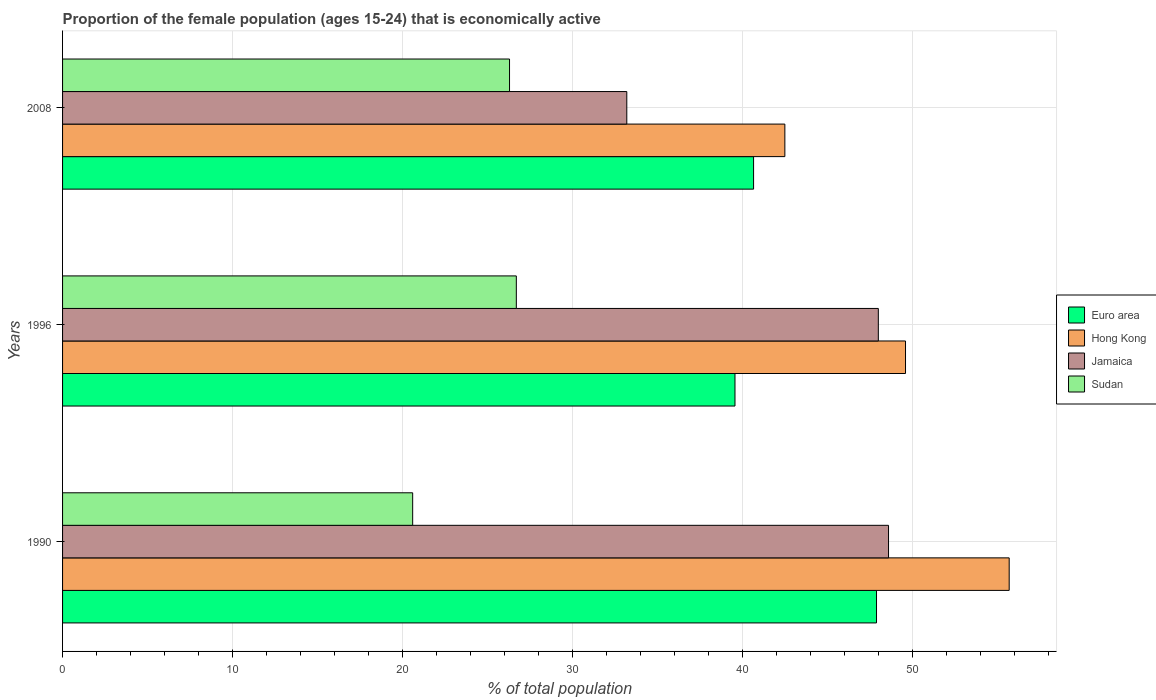How many groups of bars are there?
Make the answer very short. 3. Are the number of bars per tick equal to the number of legend labels?
Offer a very short reply. Yes. How many bars are there on the 2nd tick from the bottom?
Offer a terse response. 4. What is the proportion of the female population that is economically active in Sudan in 1996?
Your answer should be very brief. 26.7. Across all years, what is the maximum proportion of the female population that is economically active in Hong Kong?
Ensure brevity in your answer.  55.7. Across all years, what is the minimum proportion of the female population that is economically active in Jamaica?
Your answer should be compact. 33.2. In which year was the proportion of the female population that is economically active in Jamaica maximum?
Provide a succinct answer. 1990. What is the total proportion of the female population that is economically active in Jamaica in the graph?
Offer a terse response. 129.8. What is the difference between the proportion of the female population that is economically active in Euro area in 1990 and that in 2008?
Provide a short and direct response. 7.23. What is the difference between the proportion of the female population that is economically active in Euro area in 1990 and the proportion of the female population that is economically active in Hong Kong in 1996?
Offer a very short reply. -1.71. What is the average proportion of the female population that is economically active in Euro area per year?
Provide a short and direct response. 42.71. In the year 1990, what is the difference between the proportion of the female population that is economically active in Hong Kong and proportion of the female population that is economically active in Sudan?
Ensure brevity in your answer.  35.1. In how many years, is the proportion of the female population that is economically active in Jamaica greater than 56 %?
Offer a very short reply. 0. What is the ratio of the proportion of the female population that is economically active in Sudan in 1996 to that in 2008?
Offer a very short reply. 1.02. Is the difference between the proportion of the female population that is economically active in Hong Kong in 1990 and 2008 greater than the difference between the proportion of the female population that is economically active in Sudan in 1990 and 2008?
Provide a succinct answer. Yes. What is the difference between the highest and the second highest proportion of the female population that is economically active in Sudan?
Provide a succinct answer. 0.4. What is the difference between the highest and the lowest proportion of the female population that is economically active in Hong Kong?
Your answer should be compact. 13.2. Is the sum of the proportion of the female population that is economically active in Jamaica in 1990 and 1996 greater than the maximum proportion of the female population that is economically active in Euro area across all years?
Your answer should be very brief. Yes. What does the 3rd bar from the top in 1996 represents?
Provide a short and direct response. Hong Kong. What does the 3rd bar from the bottom in 1996 represents?
Offer a terse response. Jamaica. Is it the case that in every year, the sum of the proportion of the female population that is economically active in Euro area and proportion of the female population that is economically active in Sudan is greater than the proportion of the female population that is economically active in Hong Kong?
Offer a very short reply. Yes. How many bars are there?
Ensure brevity in your answer.  12. What is the difference between two consecutive major ticks on the X-axis?
Keep it short and to the point. 10. Does the graph contain any zero values?
Your answer should be very brief. No. Does the graph contain grids?
Your answer should be compact. Yes. What is the title of the graph?
Ensure brevity in your answer.  Proportion of the female population (ages 15-24) that is economically active. What is the label or title of the X-axis?
Make the answer very short. % of total population. What is the % of total population in Euro area in 1990?
Provide a succinct answer. 47.89. What is the % of total population in Hong Kong in 1990?
Your answer should be compact. 55.7. What is the % of total population in Jamaica in 1990?
Your response must be concise. 48.6. What is the % of total population in Sudan in 1990?
Offer a very short reply. 20.6. What is the % of total population of Euro area in 1996?
Provide a short and direct response. 39.57. What is the % of total population in Hong Kong in 1996?
Provide a succinct answer. 49.6. What is the % of total population of Jamaica in 1996?
Provide a succinct answer. 48. What is the % of total population of Sudan in 1996?
Offer a terse response. 26.7. What is the % of total population of Euro area in 2008?
Provide a short and direct response. 40.66. What is the % of total population in Hong Kong in 2008?
Provide a succinct answer. 42.5. What is the % of total population of Jamaica in 2008?
Offer a very short reply. 33.2. What is the % of total population of Sudan in 2008?
Offer a very short reply. 26.3. Across all years, what is the maximum % of total population of Euro area?
Offer a terse response. 47.89. Across all years, what is the maximum % of total population in Hong Kong?
Your answer should be very brief. 55.7. Across all years, what is the maximum % of total population of Jamaica?
Provide a succinct answer. 48.6. Across all years, what is the maximum % of total population of Sudan?
Make the answer very short. 26.7. Across all years, what is the minimum % of total population of Euro area?
Offer a very short reply. 39.57. Across all years, what is the minimum % of total population of Hong Kong?
Keep it short and to the point. 42.5. Across all years, what is the minimum % of total population in Jamaica?
Your answer should be very brief. 33.2. Across all years, what is the minimum % of total population in Sudan?
Your answer should be compact. 20.6. What is the total % of total population of Euro area in the graph?
Your answer should be compact. 128.12. What is the total % of total population in Hong Kong in the graph?
Your response must be concise. 147.8. What is the total % of total population in Jamaica in the graph?
Provide a succinct answer. 129.8. What is the total % of total population in Sudan in the graph?
Give a very brief answer. 73.6. What is the difference between the % of total population in Euro area in 1990 and that in 1996?
Your response must be concise. 8.33. What is the difference between the % of total population in Jamaica in 1990 and that in 1996?
Keep it short and to the point. 0.6. What is the difference between the % of total population in Euro area in 1990 and that in 2008?
Offer a terse response. 7.23. What is the difference between the % of total population of Jamaica in 1990 and that in 2008?
Keep it short and to the point. 15.4. What is the difference between the % of total population of Sudan in 1990 and that in 2008?
Ensure brevity in your answer.  -5.7. What is the difference between the % of total population of Euro area in 1996 and that in 2008?
Your response must be concise. -1.09. What is the difference between the % of total population of Hong Kong in 1996 and that in 2008?
Provide a succinct answer. 7.1. What is the difference between the % of total population of Jamaica in 1996 and that in 2008?
Your answer should be compact. 14.8. What is the difference between the % of total population in Sudan in 1996 and that in 2008?
Give a very brief answer. 0.4. What is the difference between the % of total population of Euro area in 1990 and the % of total population of Hong Kong in 1996?
Your response must be concise. -1.71. What is the difference between the % of total population in Euro area in 1990 and the % of total population in Jamaica in 1996?
Your answer should be very brief. -0.11. What is the difference between the % of total population in Euro area in 1990 and the % of total population in Sudan in 1996?
Your answer should be compact. 21.19. What is the difference between the % of total population in Hong Kong in 1990 and the % of total population in Sudan in 1996?
Provide a succinct answer. 29. What is the difference between the % of total population in Jamaica in 1990 and the % of total population in Sudan in 1996?
Offer a very short reply. 21.9. What is the difference between the % of total population in Euro area in 1990 and the % of total population in Hong Kong in 2008?
Provide a succinct answer. 5.39. What is the difference between the % of total population in Euro area in 1990 and the % of total population in Jamaica in 2008?
Offer a very short reply. 14.69. What is the difference between the % of total population in Euro area in 1990 and the % of total population in Sudan in 2008?
Provide a short and direct response. 21.59. What is the difference between the % of total population of Hong Kong in 1990 and the % of total population of Sudan in 2008?
Provide a short and direct response. 29.4. What is the difference between the % of total population of Jamaica in 1990 and the % of total population of Sudan in 2008?
Your answer should be compact. 22.3. What is the difference between the % of total population of Euro area in 1996 and the % of total population of Hong Kong in 2008?
Your answer should be compact. -2.93. What is the difference between the % of total population in Euro area in 1996 and the % of total population in Jamaica in 2008?
Offer a very short reply. 6.37. What is the difference between the % of total population in Euro area in 1996 and the % of total population in Sudan in 2008?
Your answer should be compact. 13.27. What is the difference between the % of total population in Hong Kong in 1996 and the % of total population in Jamaica in 2008?
Your response must be concise. 16.4. What is the difference between the % of total population in Hong Kong in 1996 and the % of total population in Sudan in 2008?
Offer a terse response. 23.3. What is the difference between the % of total population in Jamaica in 1996 and the % of total population in Sudan in 2008?
Give a very brief answer. 21.7. What is the average % of total population of Euro area per year?
Your response must be concise. 42.71. What is the average % of total population in Hong Kong per year?
Your answer should be compact. 49.27. What is the average % of total population of Jamaica per year?
Your response must be concise. 43.27. What is the average % of total population in Sudan per year?
Keep it short and to the point. 24.53. In the year 1990, what is the difference between the % of total population of Euro area and % of total population of Hong Kong?
Keep it short and to the point. -7.81. In the year 1990, what is the difference between the % of total population of Euro area and % of total population of Jamaica?
Your answer should be very brief. -0.71. In the year 1990, what is the difference between the % of total population in Euro area and % of total population in Sudan?
Your response must be concise. 27.29. In the year 1990, what is the difference between the % of total population in Hong Kong and % of total population in Jamaica?
Provide a succinct answer. 7.1. In the year 1990, what is the difference between the % of total population in Hong Kong and % of total population in Sudan?
Make the answer very short. 35.1. In the year 1990, what is the difference between the % of total population of Jamaica and % of total population of Sudan?
Provide a short and direct response. 28. In the year 1996, what is the difference between the % of total population in Euro area and % of total population in Hong Kong?
Offer a terse response. -10.03. In the year 1996, what is the difference between the % of total population of Euro area and % of total population of Jamaica?
Offer a terse response. -8.43. In the year 1996, what is the difference between the % of total population in Euro area and % of total population in Sudan?
Your answer should be compact. 12.87. In the year 1996, what is the difference between the % of total population in Hong Kong and % of total population in Jamaica?
Provide a short and direct response. 1.6. In the year 1996, what is the difference between the % of total population of Hong Kong and % of total population of Sudan?
Offer a very short reply. 22.9. In the year 1996, what is the difference between the % of total population of Jamaica and % of total population of Sudan?
Provide a succinct answer. 21.3. In the year 2008, what is the difference between the % of total population in Euro area and % of total population in Hong Kong?
Give a very brief answer. -1.84. In the year 2008, what is the difference between the % of total population in Euro area and % of total population in Jamaica?
Make the answer very short. 7.46. In the year 2008, what is the difference between the % of total population of Euro area and % of total population of Sudan?
Provide a short and direct response. 14.36. In the year 2008, what is the difference between the % of total population of Hong Kong and % of total population of Jamaica?
Your answer should be compact. 9.3. What is the ratio of the % of total population of Euro area in 1990 to that in 1996?
Ensure brevity in your answer.  1.21. What is the ratio of the % of total population of Hong Kong in 1990 to that in 1996?
Provide a succinct answer. 1.12. What is the ratio of the % of total population of Jamaica in 1990 to that in 1996?
Your response must be concise. 1.01. What is the ratio of the % of total population in Sudan in 1990 to that in 1996?
Offer a very short reply. 0.77. What is the ratio of the % of total population in Euro area in 1990 to that in 2008?
Provide a short and direct response. 1.18. What is the ratio of the % of total population of Hong Kong in 1990 to that in 2008?
Provide a succinct answer. 1.31. What is the ratio of the % of total population in Jamaica in 1990 to that in 2008?
Your answer should be very brief. 1.46. What is the ratio of the % of total population in Sudan in 1990 to that in 2008?
Make the answer very short. 0.78. What is the ratio of the % of total population of Euro area in 1996 to that in 2008?
Your answer should be compact. 0.97. What is the ratio of the % of total population of Hong Kong in 1996 to that in 2008?
Keep it short and to the point. 1.17. What is the ratio of the % of total population in Jamaica in 1996 to that in 2008?
Ensure brevity in your answer.  1.45. What is the ratio of the % of total population of Sudan in 1996 to that in 2008?
Make the answer very short. 1.02. What is the difference between the highest and the second highest % of total population in Euro area?
Your response must be concise. 7.23. What is the difference between the highest and the second highest % of total population in Jamaica?
Provide a short and direct response. 0.6. What is the difference between the highest and the second highest % of total population of Sudan?
Provide a short and direct response. 0.4. What is the difference between the highest and the lowest % of total population in Euro area?
Offer a terse response. 8.33. What is the difference between the highest and the lowest % of total population of Jamaica?
Offer a very short reply. 15.4. What is the difference between the highest and the lowest % of total population of Sudan?
Your response must be concise. 6.1. 